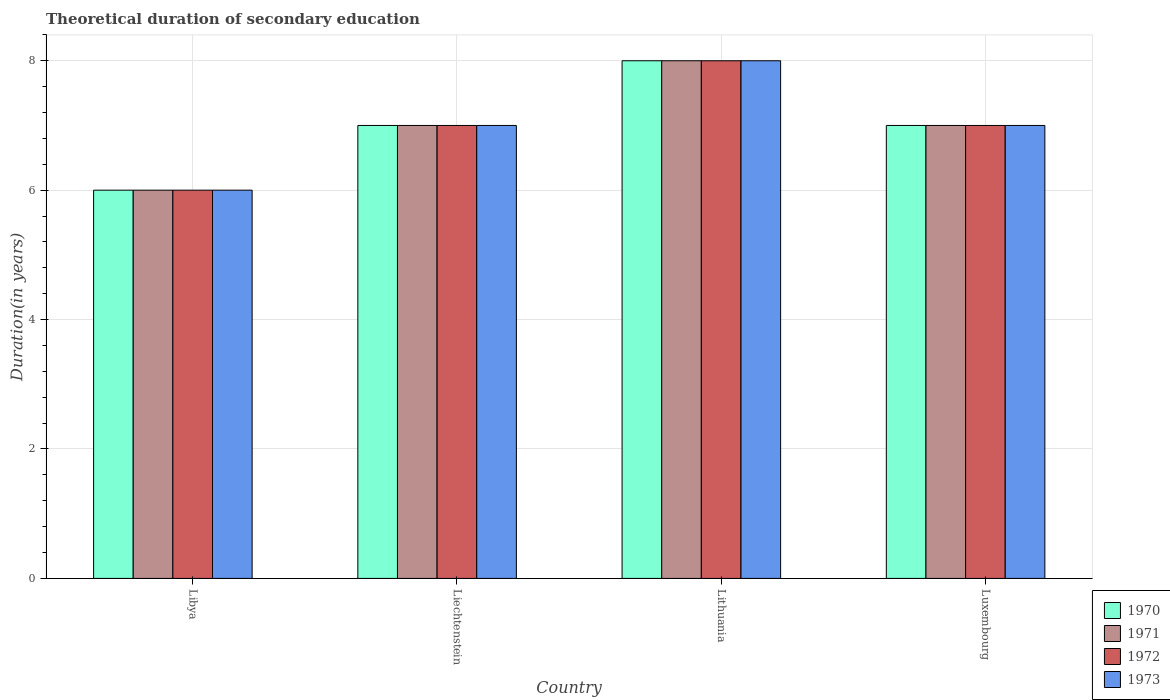How many different coloured bars are there?
Offer a terse response. 4. How many groups of bars are there?
Your answer should be compact. 4. Are the number of bars per tick equal to the number of legend labels?
Ensure brevity in your answer.  Yes. How many bars are there on the 3rd tick from the left?
Offer a very short reply. 4. What is the label of the 1st group of bars from the left?
Provide a short and direct response. Libya. What is the total theoretical duration of secondary education in 1971 in Luxembourg?
Offer a very short reply. 7. Across all countries, what is the maximum total theoretical duration of secondary education in 1973?
Give a very brief answer. 8. Across all countries, what is the minimum total theoretical duration of secondary education in 1973?
Provide a succinct answer. 6. In which country was the total theoretical duration of secondary education in 1973 maximum?
Ensure brevity in your answer.  Lithuania. In which country was the total theoretical duration of secondary education in 1970 minimum?
Offer a terse response. Libya. What is the difference between the total theoretical duration of secondary education in 1971 in Luxembourg and the total theoretical duration of secondary education in 1970 in Liechtenstein?
Ensure brevity in your answer.  0. What is the ratio of the total theoretical duration of secondary education in 1970 in Lithuania to that in Luxembourg?
Your answer should be compact. 1.14. Is the difference between the total theoretical duration of secondary education in 1973 in Libya and Lithuania greater than the difference between the total theoretical duration of secondary education in 1971 in Libya and Lithuania?
Ensure brevity in your answer.  No. What is the difference between the highest and the lowest total theoretical duration of secondary education in 1972?
Your answer should be very brief. 2. Is it the case that in every country, the sum of the total theoretical duration of secondary education in 1971 and total theoretical duration of secondary education in 1973 is greater than the sum of total theoretical duration of secondary education in 1970 and total theoretical duration of secondary education in 1972?
Your answer should be compact. No. What does the 2nd bar from the left in Luxembourg represents?
Offer a terse response. 1971. What does the 2nd bar from the right in Libya represents?
Provide a short and direct response. 1972. How many bars are there?
Your answer should be compact. 16. Are all the bars in the graph horizontal?
Keep it short and to the point. No. How many countries are there in the graph?
Provide a short and direct response. 4. Are the values on the major ticks of Y-axis written in scientific E-notation?
Give a very brief answer. No. Does the graph contain grids?
Make the answer very short. Yes. Where does the legend appear in the graph?
Make the answer very short. Bottom right. How many legend labels are there?
Provide a short and direct response. 4. How are the legend labels stacked?
Offer a very short reply. Vertical. What is the title of the graph?
Offer a very short reply. Theoretical duration of secondary education. What is the label or title of the X-axis?
Give a very brief answer. Country. What is the label or title of the Y-axis?
Your answer should be very brief. Duration(in years). What is the Duration(in years) in 1973 in Libya?
Your answer should be very brief. 6. What is the Duration(in years) in 1971 in Liechtenstein?
Your answer should be very brief. 7. What is the Duration(in years) of 1972 in Liechtenstein?
Your answer should be compact. 7. What is the Duration(in years) of 1970 in Lithuania?
Give a very brief answer. 8. What is the Duration(in years) of 1973 in Luxembourg?
Your answer should be compact. 7. Across all countries, what is the maximum Duration(in years) of 1971?
Provide a short and direct response. 8. Across all countries, what is the maximum Duration(in years) of 1972?
Make the answer very short. 8. Across all countries, what is the maximum Duration(in years) in 1973?
Your answer should be compact. 8. Across all countries, what is the minimum Duration(in years) in 1970?
Make the answer very short. 6. Across all countries, what is the minimum Duration(in years) of 1971?
Ensure brevity in your answer.  6. Across all countries, what is the minimum Duration(in years) of 1973?
Make the answer very short. 6. What is the total Duration(in years) of 1971 in the graph?
Your answer should be very brief. 28. What is the total Duration(in years) of 1972 in the graph?
Give a very brief answer. 28. What is the difference between the Duration(in years) of 1973 in Libya and that in Liechtenstein?
Offer a very short reply. -1. What is the difference between the Duration(in years) of 1970 in Libya and that in Lithuania?
Offer a very short reply. -2. What is the difference between the Duration(in years) of 1971 in Libya and that in Lithuania?
Offer a very short reply. -2. What is the difference between the Duration(in years) in 1972 in Libya and that in Lithuania?
Your answer should be very brief. -2. What is the difference between the Duration(in years) of 1970 in Libya and that in Luxembourg?
Provide a short and direct response. -1. What is the difference between the Duration(in years) of 1972 in Libya and that in Luxembourg?
Keep it short and to the point. -1. What is the difference between the Duration(in years) of 1972 in Liechtenstein and that in Lithuania?
Your response must be concise. -1. What is the difference between the Duration(in years) in 1973 in Liechtenstein and that in Lithuania?
Make the answer very short. -1. What is the difference between the Duration(in years) of 1971 in Liechtenstein and that in Luxembourg?
Give a very brief answer. 0. What is the difference between the Duration(in years) in 1972 in Liechtenstein and that in Luxembourg?
Offer a very short reply. 0. What is the difference between the Duration(in years) of 1970 in Lithuania and that in Luxembourg?
Ensure brevity in your answer.  1. What is the difference between the Duration(in years) in 1972 in Lithuania and that in Luxembourg?
Ensure brevity in your answer.  1. What is the difference between the Duration(in years) in 1973 in Lithuania and that in Luxembourg?
Your response must be concise. 1. What is the difference between the Duration(in years) in 1970 in Libya and the Duration(in years) in 1971 in Liechtenstein?
Offer a terse response. -1. What is the difference between the Duration(in years) of 1970 in Libya and the Duration(in years) of 1972 in Liechtenstein?
Keep it short and to the point. -1. What is the difference between the Duration(in years) of 1971 in Libya and the Duration(in years) of 1972 in Liechtenstein?
Offer a very short reply. -1. What is the difference between the Duration(in years) of 1971 in Libya and the Duration(in years) of 1973 in Liechtenstein?
Your answer should be very brief. -1. What is the difference between the Duration(in years) of 1970 in Libya and the Duration(in years) of 1973 in Lithuania?
Ensure brevity in your answer.  -2. What is the difference between the Duration(in years) of 1971 in Libya and the Duration(in years) of 1973 in Lithuania?
Your response must be concise. -2. What is the difference between the Duration(in years) in 1972 in Libya and the Duration(in years) in 1973 in Lithuania?
Offer a very short reply. -2. What is the difference between the Duration(in years) in 1970 in Libya and the Duration(in years) in 1971 in Luxembourg?
Provide a short and direct response. -1. What is the difference between the Duration(in years) in 1970 in Libya and the Duration(in years) in 1972 in Luxembourg?
Provide a short and direct response. -1. What is the difference between the Duration(in years) of 1971 in Libya and the Duration(in years) of 1973 in Luxembourg?
Keep it short and to the point. -1. What is the difference between the Duration(in years) in 1972 in Libya and the Duration(in years) in 1973 in Luxembourg?
Your answer should be very brief. -1. What is the difference between the Duration(in years) of 1970 in Liechtenstein and the Duration(in years) of 1971 in Lithuania?
Give a very brief answer. -1. What is the difference between the Duration(in years) of 1970 in Liechtenstein and the Duration(in years) of 1972 in Lithuania?
Provide a short and direct response. -1. What is the difference between the Duration(in years) in 1970 in Liechtenstein and the Duration(in years) in 1973 in Lithuania?
Keep it short and to the point. -1. What is the difference between the Duration(in years) of 1971 in Liechtenstein and the Duration(in years) of 1972 in Lithuania?
Your answer should be very brief. -1. What is the difference between the Duration(in years) of 1971 in Liechtenstein and the Duration(in years) of 1972 in Luxembourg?
Provide a succinct answer. 0. What is the difference between the Duration(in years) in 1972 in Liechtenstein and the Duration(in years) in 1973 in Luxembourg?
Your answer should be very brief. 0. What is the difference between the Duration(in years) of 1970 in Lithuania and the Duration(in years) of 1971 in Luxembourg?
Provide a short and direct response. 1. What is the difference between the Duration(in years) of 1970 in Lithuania and the Duration(in years) of 1972 in Luxembourg?
Give a very brief answer. 1. What is the difference between the Duration(in years) in 1970 in Lithuania and the Duration(in years) in 1973 in Luxembourg?
Offer a terse response. 1. What is the difference between the Duration(in years) of 1971 in Lithuania and the Duration(in years) of 1972 in Luxembourg?
Your answer should be very brief. 1. What is the difference between the Duration(in years) of 1971 in Lithuania and the Duration(in years) of 1973 in Luxembourg?
Offer a terse response. 1. What is the average Duration(in years) in 1970 per country?
Offer a terse response. 7. What is the average Duration(in years) in 1972 per country?
Provide a succinct answer. 7. What is the difference between the Duration(in years) in 1970 and Duration(in years) in 1972 in Libya?
Provide a short and direct response. 0. What is the difference between the Duration(in years) of 1970 and Duration(in years) of 1973 in Libya?
Provide a short and direct response. 0. What is the difference between the Duration(in years) of 1972 and Duration(in years) of 1973 in Libya?
Make the answer very short. 0. What is the difference between the Duration(in years) of 1970 and Duration(in years) of 1972 in Liechtenstein?
Make the answer very short. 0. What is the difference between the Duration(in years) of 1971 and Duration(in years) of 1973 in Liechtenstein?
Offer a very short reply. 0. What is the difference between the Duration(in years) in 1970 and Duration(in years) in 1971 in Lithuania?
Offer a terse response. 0. What is the difference between the Duration(in years) of 1970 and Duration(in years) of 1972 in Lithuania?
Offer a terse response. 0. What is the difference between the Duration(in years) in 1970 and Duration(in years) in 1973 in Lithuania?
Your answer should be compact. 0. What is the difference between the Duration(in years) in 1971 and Duration(in years) in 1972 in Lithuania?
Offer a very short reply. 0. What is the difference between the Duration(in years) in 1971 and Duration(in years) in 1973 in Lithuania?
Offer a very short reply. 0. What is the difference between the Duration(in years) of 1972 and Duration(in years) of 1973 in Lithuania?
Ensure brevity in your answer.  0. What is the difference between the Duration(in years) in 1970 and Duration(in years) in 1972 in Luxembourg?
Ensure brevity in your answer.  0. What is the difference between the Duration(in years) of 1972 and Duration(in years) of 1973 in Luxembourg?
Keep it short and to the point. 0. What is the ratio of the Duration(in years) of 1971 in Libya to that in Liechtenstein?
Your response must be concise. 0.86. What is the ratio of the Duration(in years) in 1972 in Libya to that in Lithuania?
Make the answer very short. 0.75. What is the ratio of the Duration(in years) of 1970 in Libya to that in Luxembourg?
Your answer should be very brief. 0.86. What is the ratio of the Duration(in years) in 1971 in Libya to that in Luxembourg?
Ensure brevity in your answer.  0.86. What is the ratio of the Duration(in years) in 1972 in Libya to that in Luxembourg?
Give a very brief answer. 0.86. What is the ratio of the Duration(in years) in 1970 in Liechtenstein to that in Lithuania?
Offer a terse response. 0.88. What is the ratio of the Duration(in years) of 1971 in Liechtenstein to that in Lithuania?
Offer a very short reply. 0.88. What is the ratio of the Duration(in years) in 1972 in Liechtenstein to that in Lithuania?
Provide a succinct answer. 0.88. What is the ratio of the Duration(in years) in 1973 in Liechtenstein to that in Luxembourg?
Give a very brief answer. 1. What is the ratio of the Duration(in years) in 1972 in Lithuania to that in Luxembourg?
Your response must be concise. 1.14. What is the ratio of the Duration(in years) of 1973 in Lithuania to that in Luxembourg?
Give a very brief answer. 1.14. What is the difference between the highest and the second highest Duration(in years) of 1972?
Make the answer very short. 1. What is the difference between the highest and the second highest Duration(in years) of 1973?
Your answer should be compact. 1. What is the difference between the highest and the lowest Duration(in years) of 1972?
Provide a succinct answer. 2. What is the difference between the highest and the lowest Duration(in years) of 1973?
Ensure brevity in your answer.  2. 